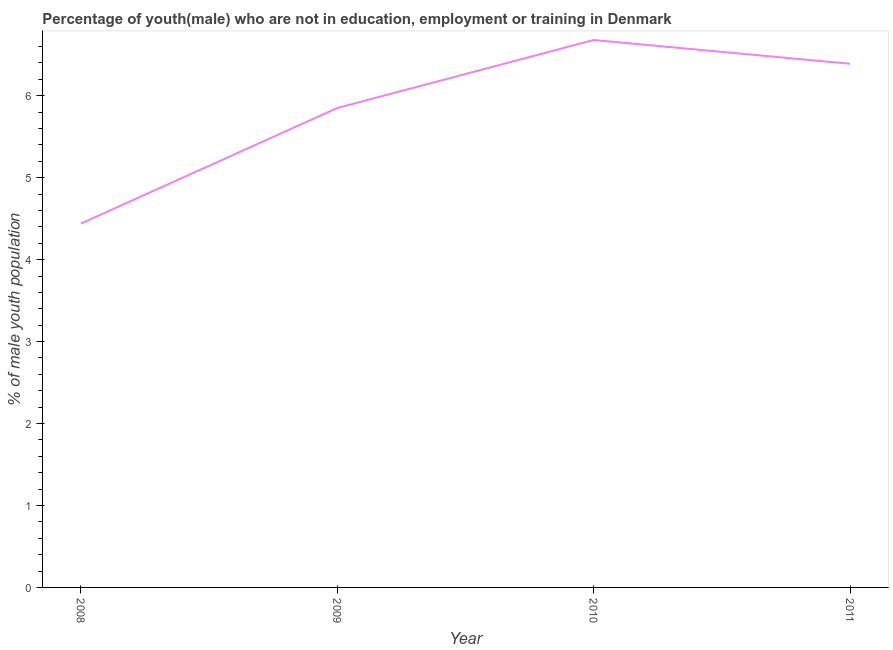What is the unemployed male youth population in 2010?
Provide a succinct answer. 6.68. Across all years, what is the maximum unemployed male youth population?
Ensure brevity in your answer.  6.68. Across all years, what is the minimum unemployed male youth population?
Give a very brief answer. 4.44. In which year was the unemployed male youth population minimum?
Offer a terse response. 2008. What is the sum of the unemployed male youth population?
Keep it short and to the point. 23.36. What is the difference between the unemployed male youth population in 2010 and 2011?
Provide a short and direct response. 0.29. What is the average unemployed male youth population per year?
Give a very brief answer. 5.84. What is the median unemployed male youth population?
Give a very brief answer. 6.12. Do a majority of the years between 2009 and 2008 (inclusive) have unemployed male youth population greater than 4.2 %?
Your answer should be compact. No. What is the ratio of the unemployed male youth population in 2009 to that in 2010?
Your answer should be very brief. 0.88. Is the difference between the unemployed male youth population in 2009 and 2011 greater than the difference between any two years?
Offer a terse response. No. What is the difference between the highest and the second highest unemployed male youth population?
Make the answer very short. 0.29. What is the difference between the highest and the lowest unemployed male youth population?
Keep it short and to the point. 2.24. How many years are there in the graph?
Make the answer very short. 4. What is the difference between two consecutive major ticks on the Y-axis?
Your response must be concise. 1. Does the graph contain grids?
Offer a terse response. No. What is the title of the graph?
Provide a succinct answer. Percentage of youth(male) who are not in education, employment or training in Denmark. What is the label or title of the X-axis?
Provide a succinct answer. Year. What is the label or title of the Y-axis?
Offer a terse response. % of male youth population. What is the % of male youth population of 2008?
Your answer should be compact. 4.44. What is the % of male youth population of 2009?
Offer a terse response. 5.85. What is the % of male youth population of 2010?
Ensure brevity in your answer.  6.68. What is the % of male youth population in 2011?
Ensure brevity in your answer.  6.39. What is the difference between the % of male youth population in 2008 and 2009?
Keep it short and to the point. -1.41. What is the difference between the % of male youth population in 2008 and 2010?
Keep it short and to the point. -2.24. What is the difference between the % of male youth population in 2008 and 2011?
Keep it short and to the point. -1.95. What is the difference between the % of male youth population in 2009 and 2010?
Provide a short and direct response. -0.83. What is the difference between the % of male youth population in 2009 and 2011?
Keep it short and to the point. -0.54. What is the difference between the % of male youth population in 2010 and 2011?
Provide a short and direct response. 0.29. What is the ratio of the % of male youth population in 2008 to that in 2009?
Your answer should be compact. 0.76. What is the ratio of the % of male youth population in 2008 to that in 2010?
Give a very brief answer. 0.67. What is the ratio of the % of male youth population in 2008 to that in 2011?
Your answer should be very brief. 0.69. What is the ratio of the % of male youth population in 2009 to that in 2010?
Offer a terse response. 0.88. What is the ratio of the % of male youth population in 2009 to that in 2011?
Give a very brief answer. 0.92. What is the ratio of the % of male youth population in 2010 to that in 2011?
Keep it short and to the point. 1.04. 